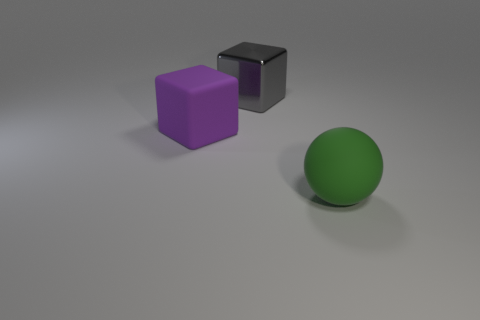Add 2 matte balls. How many objects exist? 5 Subtract all spheres. How many objects are left? 2 Add 2 tiny yellow rubber blocks. How many tiny yellow rubber blocks exist? 2 Subtract 0 purple spheres. How many objects are left? 3 Subtract all gray cubes. Subtract all purple matte objects. How many objects are left? 1 Add 3 gray metallic cubes. How many gray metallic cubes are left? 4 